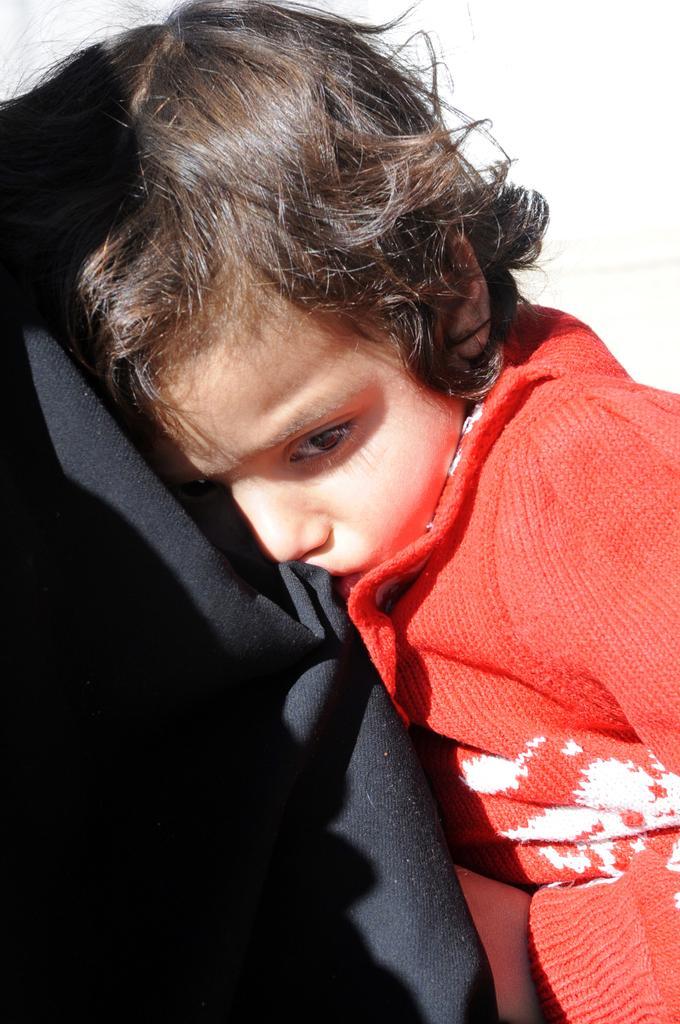Can you describe this image briefly? There is a kid on black cloth. In the background it is white. 